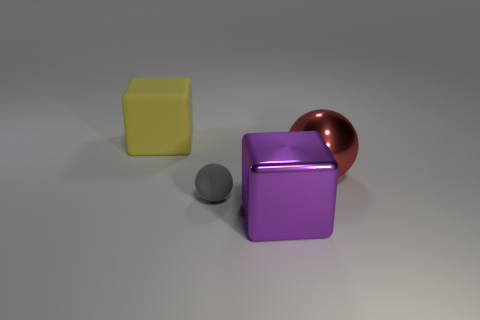Are the objects arranged in any particular pattern? The objects appear to be arranged randomly on a flat surface with no discernible pattern. There is a small space between each object, suggesting they are independent from each other.  What could be the significance of these objects being together? While there's no inherent significance to the arrangement, this image could represent a study in contrast—different geometric shapes and colors could symbolize diversity or individuality. Alternatively, it might be a simple 3D rendering used for visual or design purposes. 